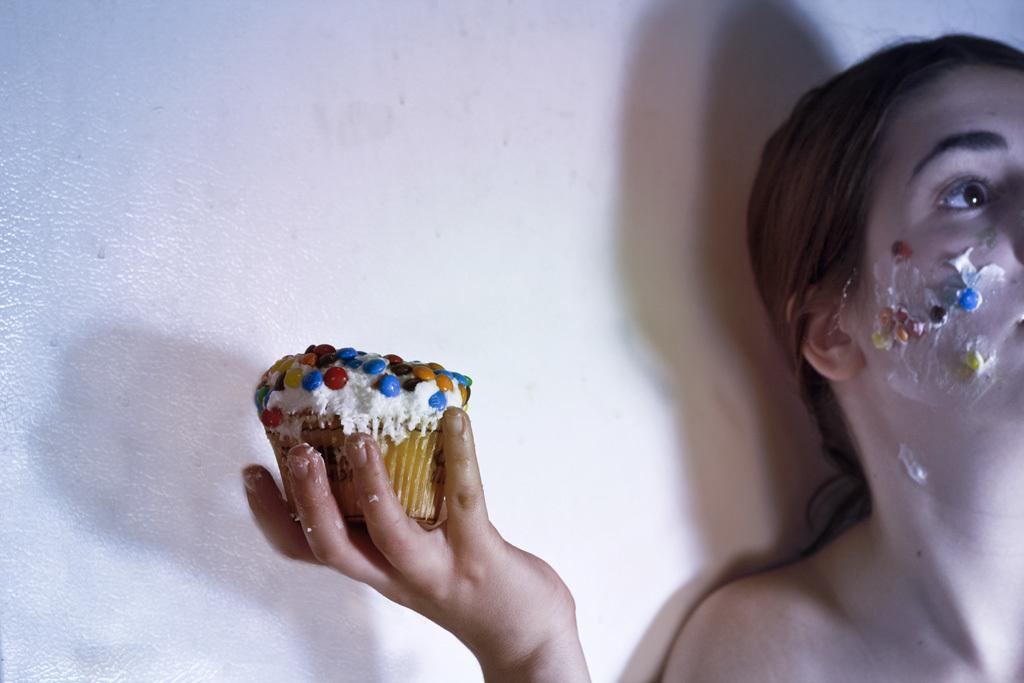Who or what is present in the image? There is a person in the image. What is the person holding? The person is holding a cupcake. Can you describe the cupcake? The cupcake has decorations that resemble candies. What can be seen in the background of the image? There is a wall visible behind the person. What type of fang can be seen on the person in the image? There are no fangs present on the person in the image. Is the person flying a kite in the image? There is no kite visible in the image. 